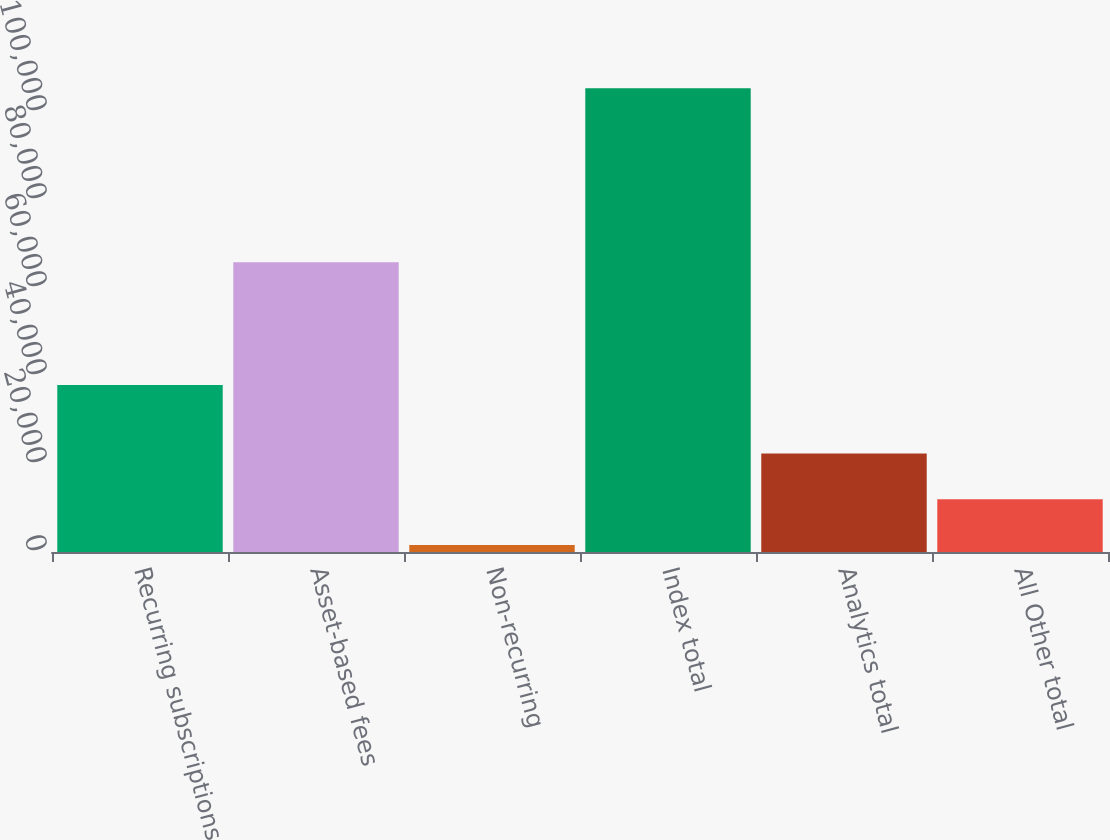<chart> <loc_0><loc_0><loc_500><loc_500><bar_chart><fcel>Recurring subscriptions<fcel>Asset-based fees<fcel>Non-recurring<fcel>Index total<fcel>Analytics total<fcel>All Other total<nl><fcel>37941<fcel>65863<fcel>1604<fcel>105408<fcel>22364.8<fcel>11984.4<nl></chart> 